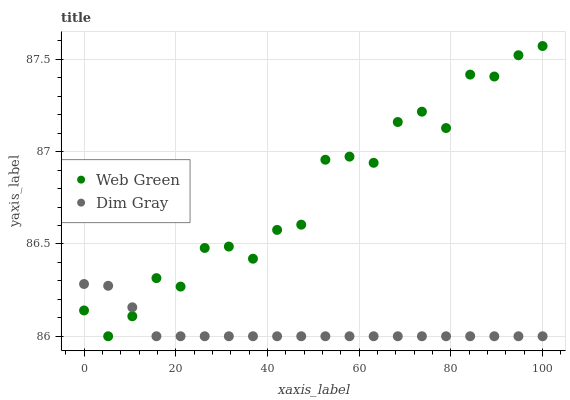Does Dim Gray have the minimum area under the curve?
Answer yes or no. Yes. Does Web Green have the maximum area under the curve?
Answer yes or no. Yes. Does Web Green have the minimum area under the curve?
Answer yes or no. No. Is Dim Gray the smoothest?
Answer yes or no. Yes. Is Web Green the roughest?
Answer yes or no. Yes. Is Web Green the smoothest?
Answer yes or no. No. Does Dim Gray have the lowest value?
Answer yes or no. Yes. Does Web Green have the highest value?
Answer yes or no. Yes. Does Dim Gray intersect Web Green?
Answer yes or no. Yes. Is Dim Gray less than Web Green?
Answer yes or no. No. Is Dim Gray greater than Web Green?
Answer yes or no. No. 